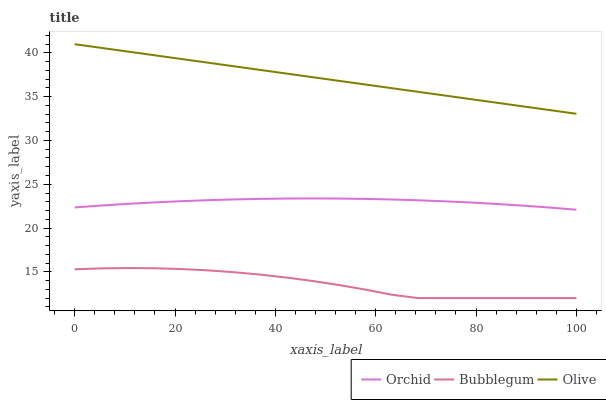Does Bubblegum have the minimum area under the curve?
Answer yes or no. Yes. Does Olive have the maximum area under the curve?
Answer yes or no. Yes. Does Orchid have the minimum area under the curve?
Answer yes or no. No. Does Orchid have the maximum area under the curve?
Answer yes or no. No. Is Olive the smoothest?
Answer yes or no. Yes. Is Bubblegum the roughest?
Answer yes or no. Yes. Is Orchid the smoothest?
Answer yes or no. No. Is Orchid the roughest?
Answer yes or no. No. Does Orchid have the lowest value?
Answer yes or no. No. Does Olive have the highest value?
Answer yes or no. Yes. Does Orchid have the highest value?
Answer yes or no. No. Is Orchid less than Olive?
Answer yes or no. Yes. Is Olive greater than Bubblegum?
Answer yes or no. Yes. Does Orchid intersect Olive?
Answer yes or no. No. 